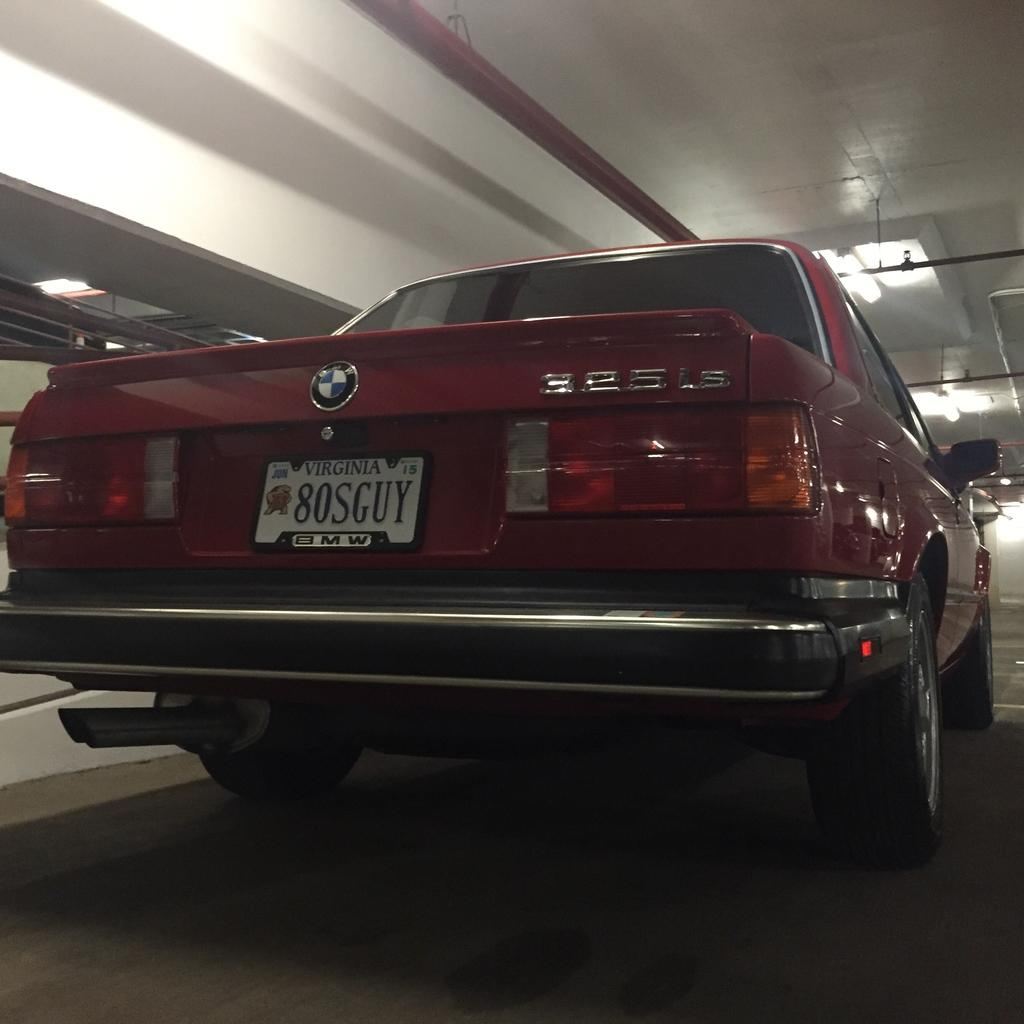Where was the image taken? The image was taken in a room. What is the main subject in the foreground of the image? There is a maroon car in the foreground of the image. What can be seen at the top of the image? There are lights and pipes visible at the top of the image. What color is the ceiling in the room? The ceiling is painted white. What type of button is being used to control the tank in the image? There is no button or tank present in the image. What color are the teeth of the person in the image? There are no people or teeth visible in the image. 